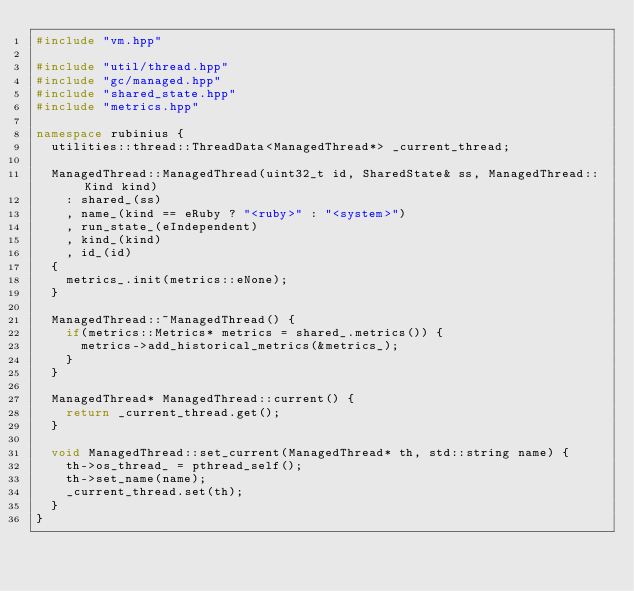Convert code to text. <code><loc_0><loc_0><loc_500><loc_500><_C++_>#include "vm.hpp"

#include "util/thread.hpp"
#include "gc/managed.hpp"
#include "shared_state.hpp"
#include "metrics.hpp"

namespace rubinius {
  utilities::thread::ThreadData<ManagedThread*> _current_thread;

  ManagedThread::ManagedThread(uint32_t id, SharedState& ss, ManagedThread::Kind kind)
    : shared_(ss)
    , name_(kind == eRuby ? "<ruby>" : "<system>")
    , run_state_(eIndependent)
    , kind_(kind)
    , id_(id)
  {
    metrics_.init(metrics::eNone);
  }

  ManagedThread::~ManagedThread() {
    if(metrics::Metrics* metrics = shared_.metrics()) {
      metrics->add_historical_metrics(&metrics_);
    }
  }

  ManagedThread* ManagedThread::current() {
    return _current_thread.get();
  }

  void ManagedThread::set_current(ManagedThread* th, std::string name) {
    th->os_thread_ = pthread_self();
    th->set_name(name);
    _current_thread.set(th);
  }
}
</code> 